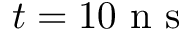<formula> <loc_0><loc_0><loc_500><loc_500>t = 1 0 n s</formula> 